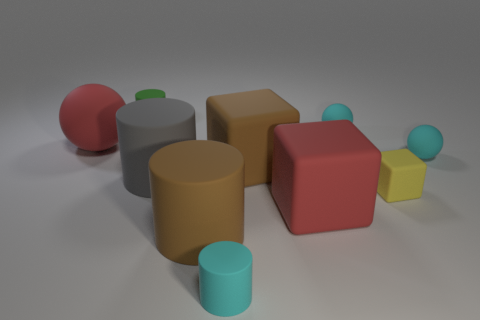What number of things are either large green metallic objects or things in front of the big gray rubber object?
Give a very brief answer. 4. There is a gray object that is the same shape as the small green thing; what material is it?
Provide a succinct answer. Rubber. Are there more green matte things that are on the left side of the tiny yellow rubber object than matte cylinders?
Your response must be concise. No. Are there any other things that are the same color as the big matte sphere?
Offer a terse response. Yes. What is the shape of the tiny green object that is the same material as the yellow object?
Your answer should be very brief. Cylinder. Is the material of the cyan object that is in front of the big red matte block the same as the yellow object?
Provide a short and direct response. Yes. The thing that is the same color as the large matte sphere is what shape?
Make the answer very short. Cube. There is a big cube that is behind the gray matte thing; is its color the same as the tiny cylinder on the left side of the small cyan cylinder?
Ensure brevity in your answer.  No. How many rubber things are on the left side of the cyan cylinder and in front of the green object?
Give a very brief answer. 3. What is the material of the large brown cube?
Ensure brevity in your answer.  Rubber. 